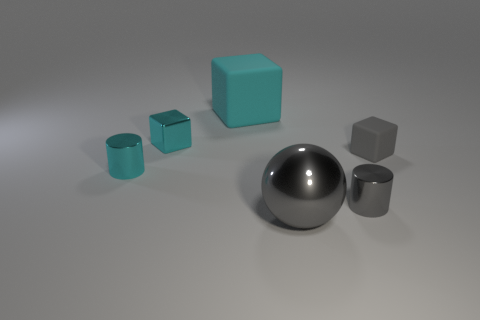Add 4 big gray metallic things. How many objects exist? 10 Subtract all balls. How many objects are left? 5 Add 3 cyan things. How many cyan things are left? 6 Add 3 metallic things. How many metallic things exist? 7 Subtract 0 red cylinders. How many objects are left? 6 Subtract all big gray balls. Subtract all tiny purple shiny cubes. How many objects are left? 5 